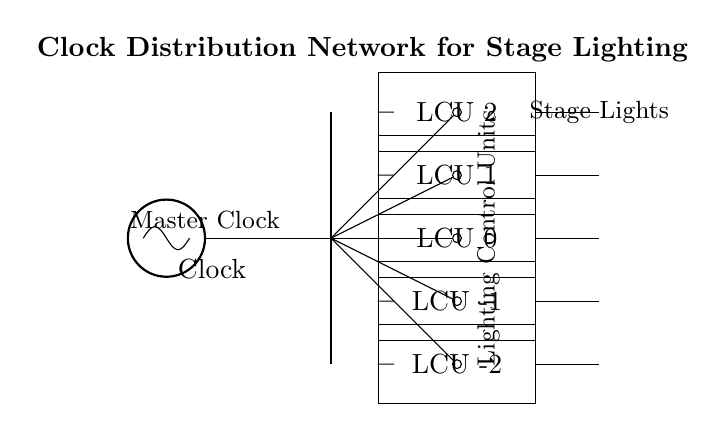What is the main component of the circuit? The main component is the Master Clock, which serves as the source of the clock signal for the distribution network.
Answer: Master Clock How many Lighting Control Units are present? There are five Lighting Control Units, as indicated by the labeled rectangles in the diagram.
Answer: Five What do the connections from the Clock to the Lighting Control Units represent? The connections represent the distribution of the clock signal from the Master Clock to each Lighting Control Unit, ensuring they are synchronized in operation.
Answer: Clock signal distribution What type of circuit is this? This is a synchronous circuit, as indicated by the use of a master clock to coordinate the operation of the lighting systems.
Answer: Synchronous Which component receives the clock signal directly? The Lighting Control Units receive the clock signal directly via their connections from the clock distribution point.
Answer: Lighting Control Units What is the orientation of the Master Clock in relation to the Lighting Control Units? The Master Clock is positioned above the Lighting Control Units, indicating a hierarchy where the clock governs their function.
Answer: Above What is the purpose of the secondary clock distribution shown in the diagram? The secondary clock distribution serves to fan out the clock signal to multiple branches, ensuring all control units receive the same timing information.
Answer: Fan-out 